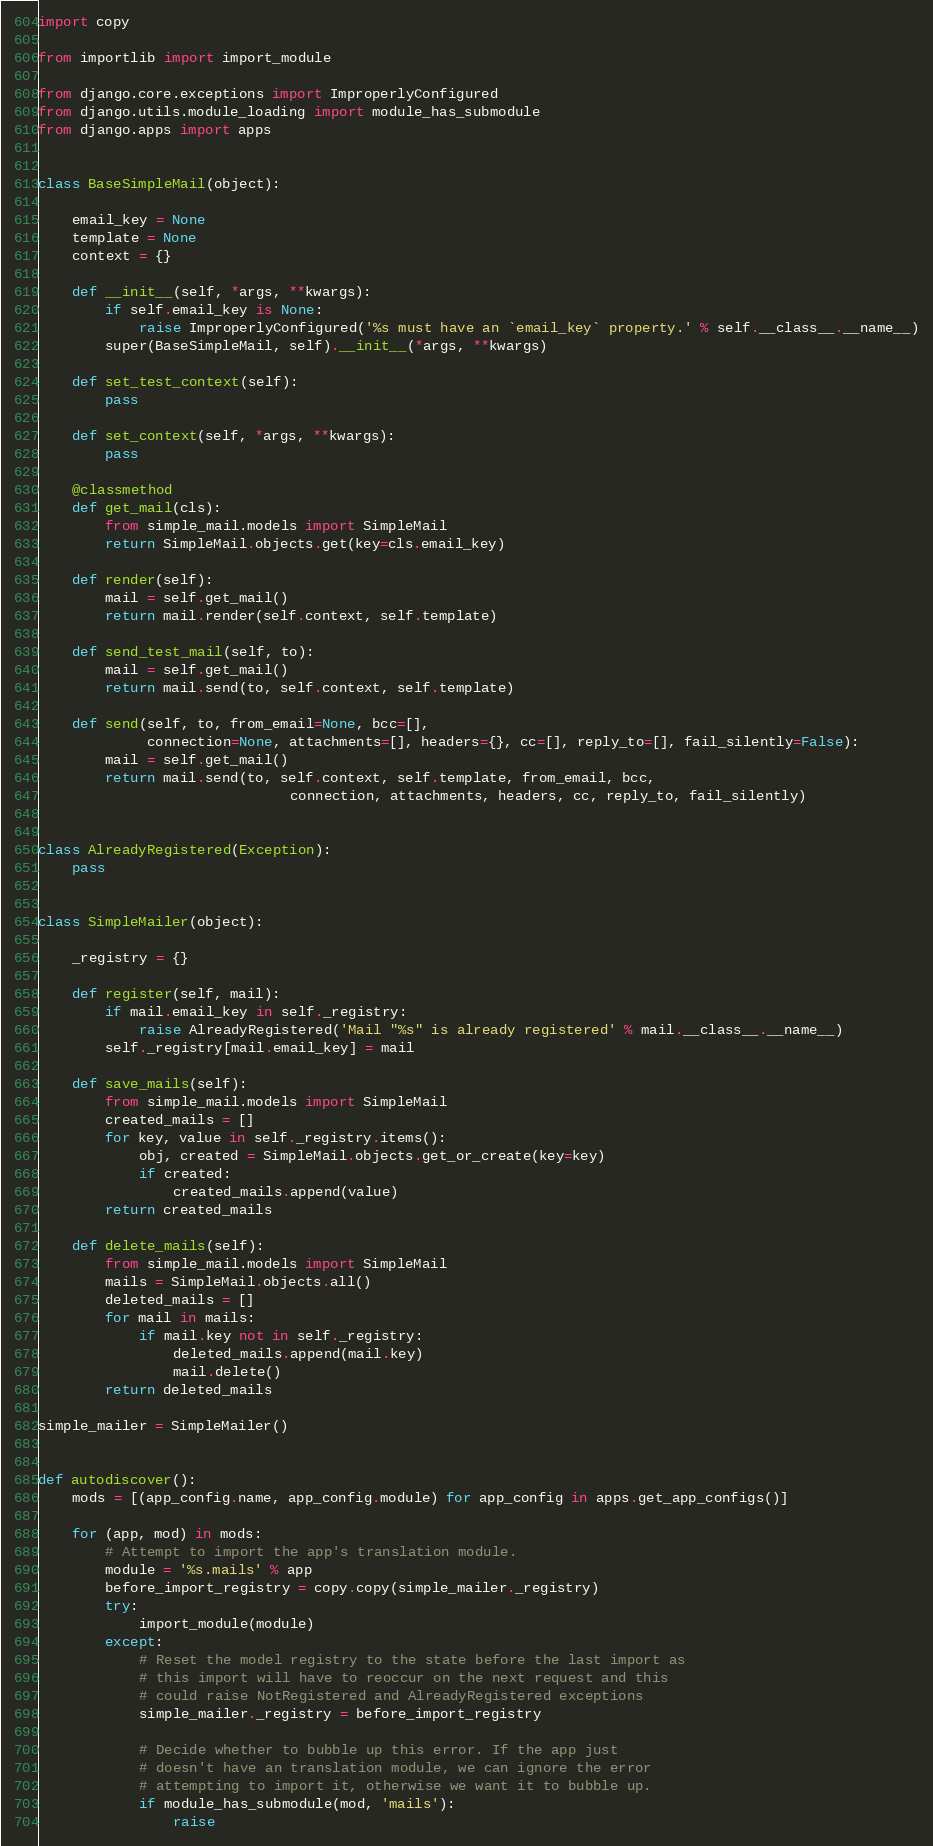Convert code to text. <code><loc_0><loc_0><loc_500><loc_500><_Python_>import copy

from importlib import import_module

from django.core.exceptions import ImproperlyConfigured
from django.utils.module_loading import module_has_submodule
from django.apps import apps


class BaseSimpleMail(object):

    email_key = None
    template = None
    context = {}

    def __init__(self, *args, **kwargs):
        if self.email_key is None:
            raise ImproperlyConfigured('%s must have an `email_key` property.' % self.__class__.__name__)
        super(BaseSimpleMail, self).__init__(*args, **kwargs)

    def set_test_context(self):
        pass
    
    def set_context(self, *args, **kwargs):
        pass

    @classmethod
    def get_mail(cls):
        from simple_mail.models import SimpleMail
        return SimpleMail.objects.get(key=cls.email_key)

    def render(self):
        mail = self.get_mail()
        return mail.render(self.context, self.template)

    def send_test_mail(self, to):
        mail = self.get_mail()
        return mail.send(to, self.context, self.template)

    def send(self, to, from_email=None, bcc=[],
             connection=None, attachments=[], headers={}, cc=[], reply_to=[], fail_silently=False):
        mail = self.get_mail()
        return mail.send(to, self.context, self.template, from_email, bcc,
                              connection, attachments, headers, cc, reply_to, fail_silently)
        

class AlreadyRegistered(Exception):
    pass


class SimpleMailer(object):

    _registry = {}

    def register(self, mail):
        if mail.email_key in self._registry:
            raise AlreadyRegistered('Mail "%s" is already registered' % mail.__class__.__name__)
        self._registry[mail.email_key] = mail
    
    def save_mails(self):
        from simple_mail.models import SimpleMail
        created_mails = []
        for key, value in self._registry.items():
            obj, created = SimpleMail.objects.get_or_create(key=key)
            if created:
                created_mails.append(value)
        return created_mails
    
    def delete_mails(self):
        from simple_mail.models import SimpleMail
        mails = SimpleMail.objects.all()
        deleted_mails = []
        for mail in mails:
            if mail.key not in self._registry:
                deleted_mails.append(mail.key)
                mail.delete()
        return deleted_mails

simple_mailer = SimpleMailer()


def autodiscover():
    mods = [(app_config.name, app_config.module) for app_config in apps.get_app_configs()]

    for (app, mod) in mods:
        # Attempt to import the app's translation module.
        module = '%s.mails' % app
        before_import_registry = copy.copy(simple_mailer._registry)
        try:
            import_module(module)
        except:
            # Reset the model registry to the state before the last import as
            # this import will have to reoccur on the next request and this
            # could raise NotRegistered and AlreadyRegistered exceptions
            simple_mailer._registry = before_import_registry

            # Decide whether to bubble up this error. If the app just
            # doesn't have an translation module, we can ignore the error
            # attempting to import it, otherwise we want it to bubble up.
            if module_has_submodule(mod, 'mails'):
                raise</code> 